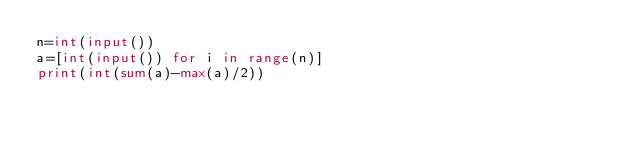<code> <loc_0><loc_0><loc_500><loc_500><_Python_>n=int(input())
a=[int(input()) for i in range(n)]
print(int(sum(a)-max(a)/2))</code> 